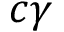Convert formula to latex. <formula><loc_0><loc_0><loc_500><loc_500>c \gamma</formula> 